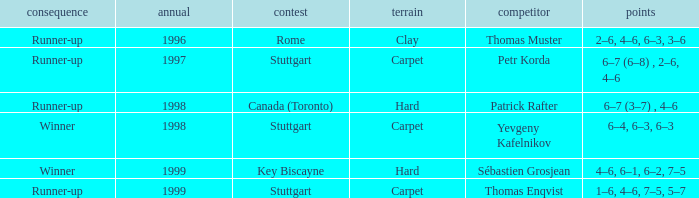What was the exterior in 1996? Clay. 